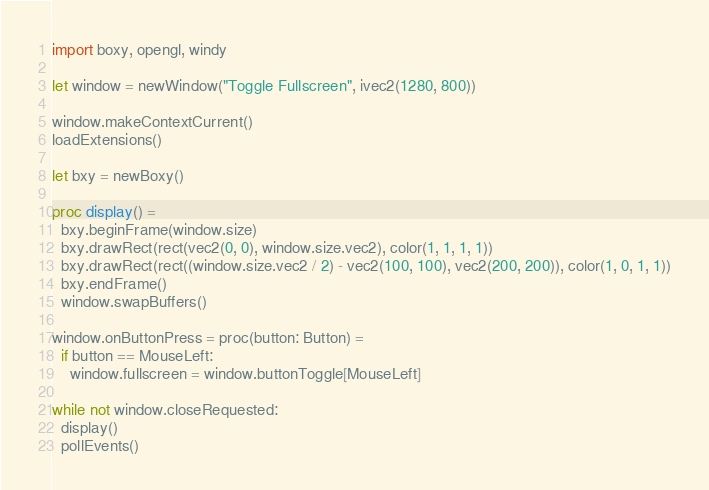<code> <loc_0><loc_0><loc_500><loc_500><_Nim_>import boxy, opengl, windy

let window = newWindow("Toggle Fullscreen", ivec2(1280, 800))

window.makeContextCurrent()
loadExtensions()

let bxy = newBoxy()

proc display() =
  bxy.beginFrame(window.size)
  bxy.drawRect(rect(vec2(0, 0), window.size.vec2), color(1, 1, 1, 1))
  bxy.drawRect(rect((window.size.vec2 / 2) - vec2(100, 100), vec2(200, 200)), color(1, 0, 1, 1))
  bxy.endFrame()
  window.swapBuffers()

window.onButtonPress = proc(button: Button) =
  if button == MouseLeft:
    window.fullscreen = window.buttonToggle[MouseLeft]

while not window.closeRequested:
  display()
  pollEvents()
</code> 